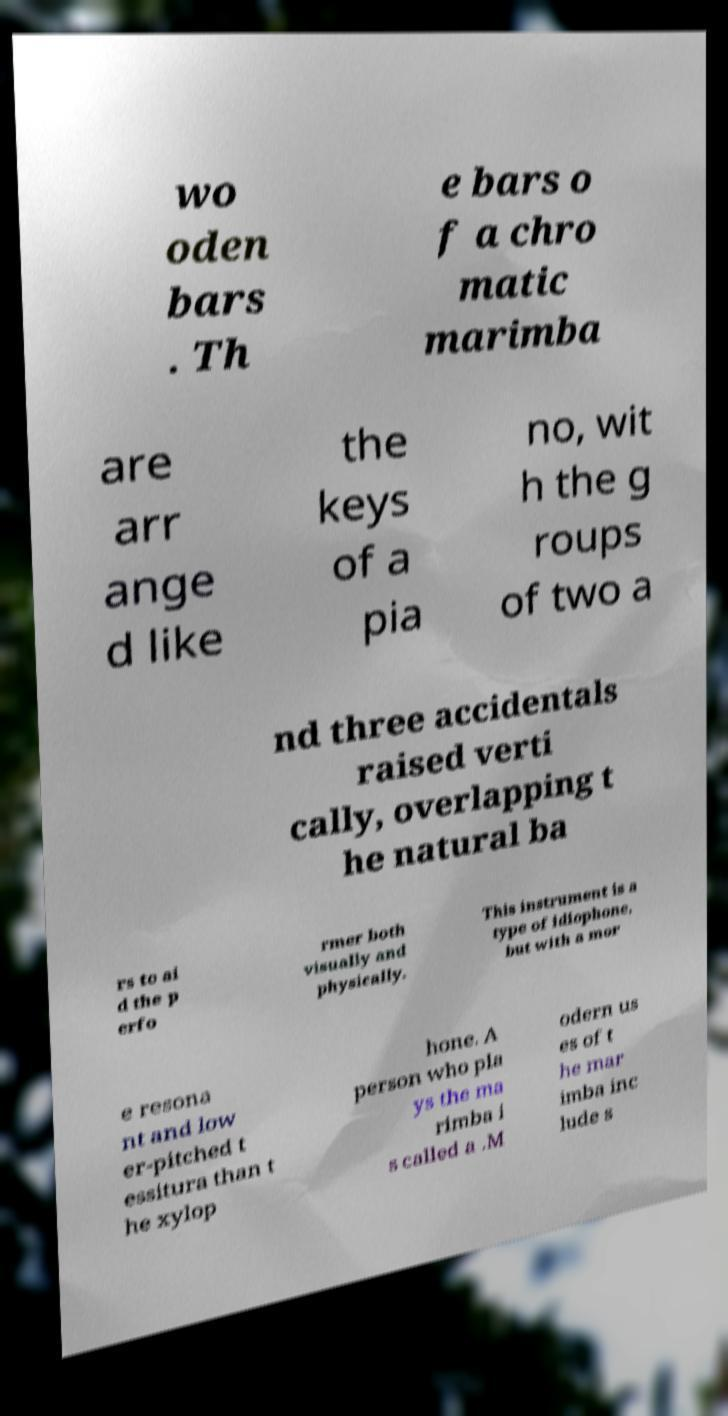For documentation purposes, I need the text within this image transcribed. Could you provide that? wo oden bars . Th e bars o f a chro matic marimba are arr ange d like the keys of a pia no, wit h the g roups of two a nd three accidentals raised verti cally, overlapping t he natural ba rs to ai d the p erfo rmer both visually and physically. This instrument is a type of idiophone, but with a mor e resona nt and low er-pitched t essitura than t he xylop hone. A person who pla ys the ma rimba i s called a .M odern us es of t he mar imba inc lude s 